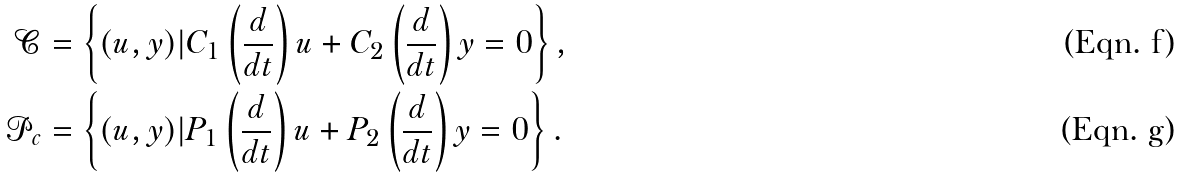Convert formula to latex. <formula><loc_0><loc_0><loc_500><loc_500>\mathcal { C } & = \left \{ ( u , y ) | C _ { 1 } \left ( \frac { d } { d t } \right ) u + C _ { 2 } \left ( \frac { d } { d t } \right ) y = 0 \right \} , \\ \mathcal { P } _ { c } & = \left \{ ( u , y ) | P _ { 1 } \left ( \frac { d } { d t } \right ) u + P _ { 2 } \left ( \frac { d } { d t } \right ) y = 0 \right \} .</formula> 